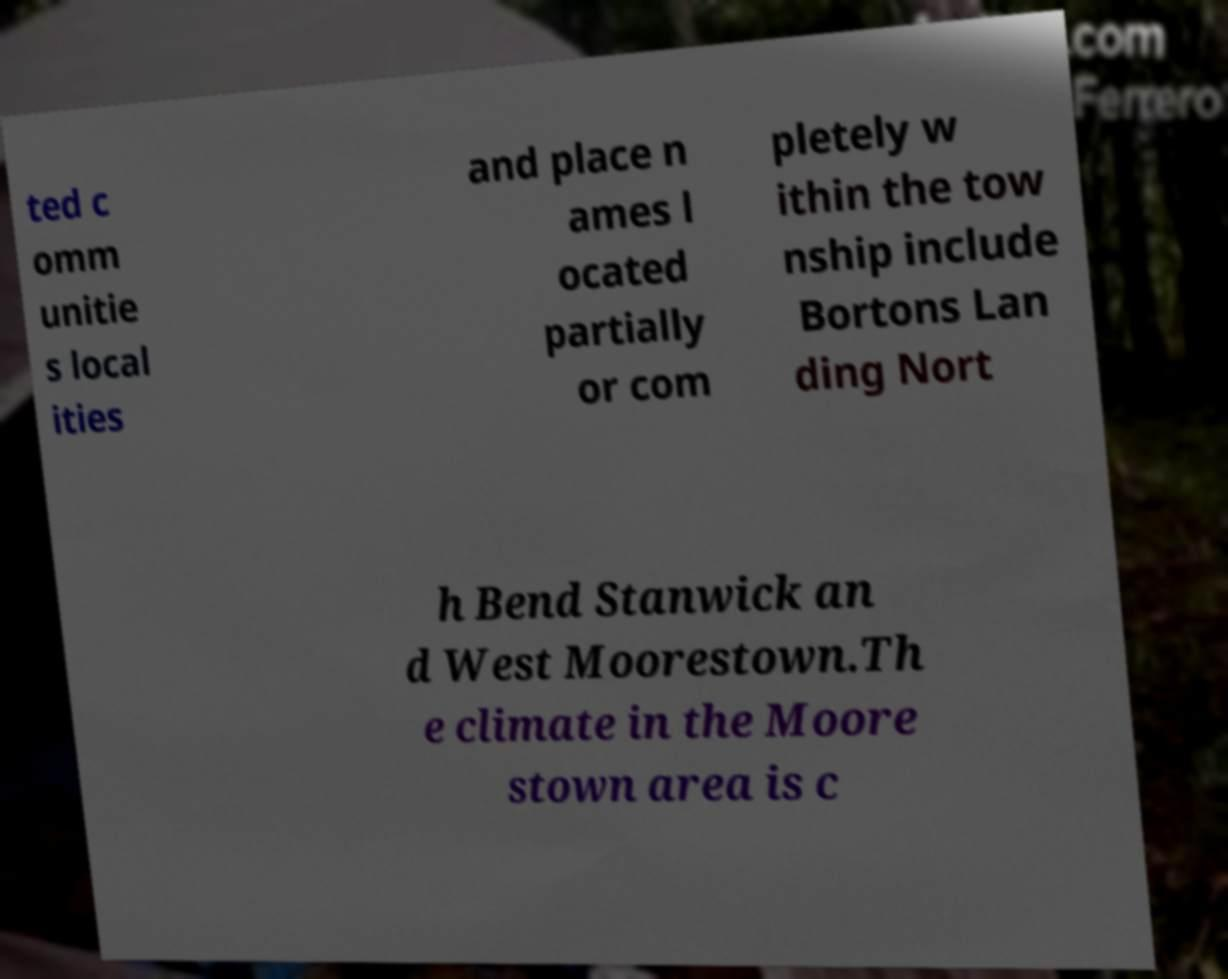Can you accurately transcribe the text from the provided image for me? ted c omm unitie s local ities and place n ames l ocated partially or com pletely w ithin the tow nship include Bortons Lan ding Nort h Bend Stanwick an d West Moorestown.Th e climate in the Moore stown area is c 